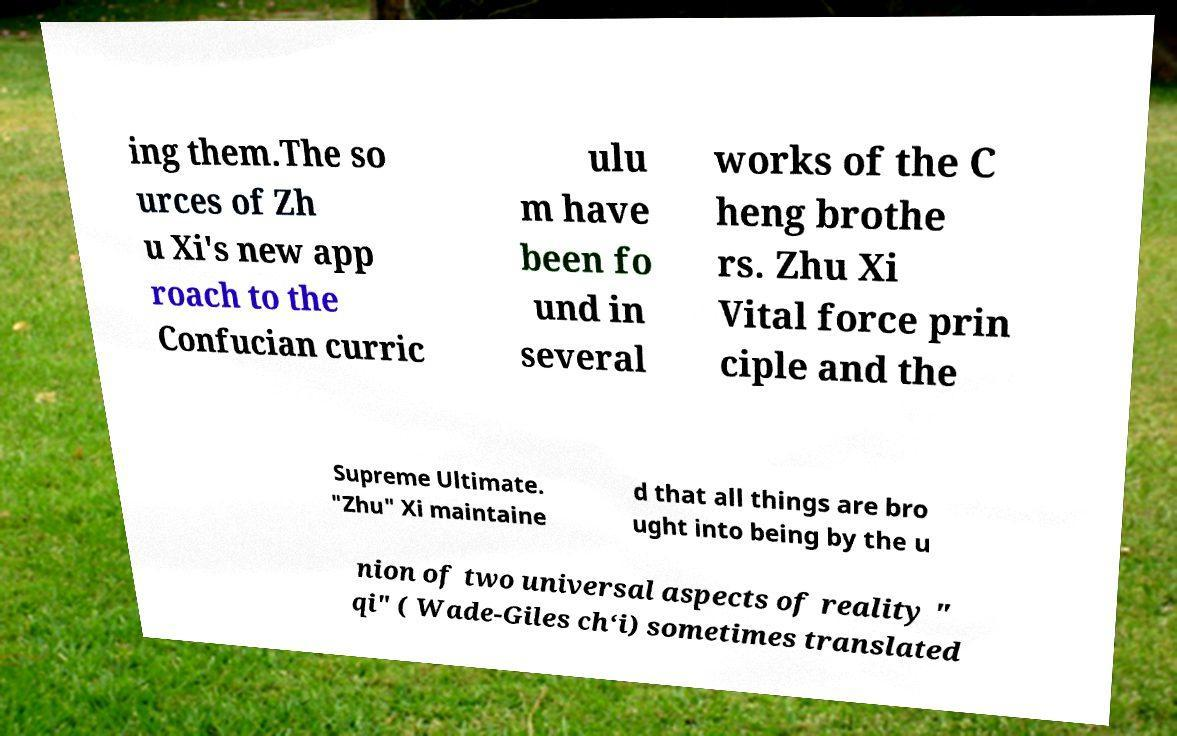Could you assist in decoding the text presented in this image and type it out clearly? ing them.The so urces of Zh u Xi's new app roach to the Confucian curric ulu m have been fo und in several works of the C heng brothe rs. Zhu Xi Vital force prin ciple and the Supreme Ultimate. "Zhu" Xi maintaine d that all things are bro ught into being by the u nion of two universal aspects of reality " qi" ( Wade-Giles ch‘i) sometimes translated 